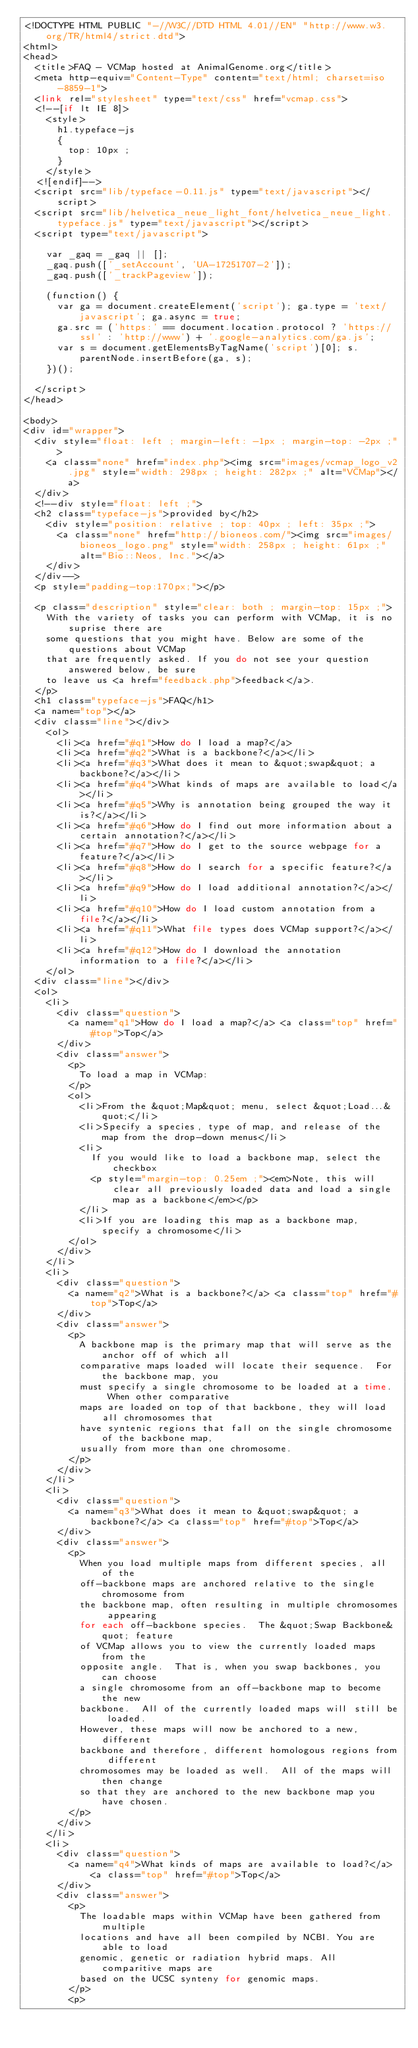<code> <loc_0><loc_0><loc_500><loc_500><_PHP_><!DOCTYPE HTML PUBLIC "-//W3C//DTD HTML 4.01//EN" "http://www.w3.org/TR/html4/strict.dtd">
<html>
<head>
  <title>FAQ - VCMap hosted at AnimalGenome.org</title>
  <meta http-equiv="Content-Type" content="text/html; charset=iso-8859-1">
  <link rel="stylesheet" type="text/css" href="vcmap.css">
  <!--[if lt IE 8]>
    <style>
      h1.typeface-js
      {
        top: 10px ;
      }
    </style>
  <![endif]-->
  <script src="lib/typeface-0.11.js" type="text/javascript"></script>
  <script src="lib/helvetica_neue_light_font/helvetica_neue_light.typeface.js" type="text/javascript"></script>
  <script type="text/javascript">

    var _gaq = _gaq || [];
    _gaq.push(['_setAccount', 'UA-17251707-2']);
    _gaq.push(['_trackPageview']);

    (function() {
      var ga = document.createElement('script'); ga.type = 'text/javascript'; ga.async = true;
      ga.src = ('https:' == document.location.protocol ? 'https://ssl' : 'http://www') + '.google-analytics.com/ga.js';
      var s = document.getElementsByTagName('script')[0]; s.parentNode.insertBefore(ga, s);
    })();

  </script>
</head>

<body>
<div id="wrapper">
  <div style="float: left ; margin-left: -1px ; margin-top: -2px ;">
    <a class="none" href="index.php"><img src="images/vcmap_logo_v2.jpg" style="width: 298px ; height: 282px ;" alt="VCMap"></a>
  </div>
  <!--div style="float: left ;">
  <h2 class="typeface-js">provided by</h2>
    <div style="position: relative ; top: 40px ; left: 35px ;">
      <a class="none" href="http://bioneos.com/"><img src="images/bioneos_logo.png" style="width: 258px ; height: 61px ;" alt="Bio::Neos, Inc."></a>
    </div>
  </div-->
  <p style="padding-top:170px;"></p>

  <p class="description" style="clear: both ; margin-top: 15px ;">
    With the variety of tasks you can perform with VCMap, it is no suprise there are
    some questions that you might have. Below are some of the questions about VCMap
    that are frequently asked. If you do not see your question answered below, be sure
    to leave us <a href="feedback.php">feedback</a>.
  </p>
  <h1 class="typeface-js">FAQ</h1>
  <a name="top"></a>
  <div class="line"></div>
    <ol>
      <li><a href="#q1">How do I load a map?</a>
      <li><a href="#q2">What is a backbone?</a></li>
      <li><a href="#q3">What does it mean to &quot;swap&quot; a backbone?</a></li>
      <li><a href="#q4">What kinds of maps are available to load</a></li>
      <li><a href="#q5">Why is annotation being grouped the way it is?</a></li>
      <li><a href="#q6">How do I find out more information about a certain annotation?</a></li>
      <li><a href="#q7">How do I get to the source webpage for a feature?</a></li>
      <li><a href="#q8">How do I search for a specific feature?</a></li>
      <li><a href="#q9">How do I load additional annotation?</a></li>
      <li><a href="#q10">How do I load custom annotation from a file?</a></li>
      <li><a href="#q11">What file types does VCMap support?</a></li>
      <li><a href="#q12">How do I download the annotation information to a file?</a></li>
    </ol>
  <div class="line"></div>
  <ol>
    <li>
      <div class="question">
        <a name="q1">How do I load a map?</a> <a class="top" href="#top">Top</a>
      </div>
      <div class="answer">
        <p>
          To load a map in VCMap:
        </p>
        <ol>
          <li>From the &quot;Map&quot; menu, select &quot;Load...&quot;</li>
          <li>Specify a species, type of map, and release of the map from the drop-down menus</li>
          <li>
            If you would like to load a backbone map, select the checkbox
            <p style="margin-top: 0.25em ;"><em>Note, this will clear all previously loaded data and load a single map as a backbone</em></p>
          </li>
          <li>If you are loading this map as a backbone map, specify a chromosome</li>
        </ol>
      </div>
    </li>
    <li>
      <div class="question">
        <a name="q2">What is a backbone?</a> <a class="top" href="#top">Top</a>
      </div>
      <div class="answer">
        <p>
          A backbone map is the primary map that will serve as the anchor off of which all
          comparative maps loaded will locate their sequence.  For the backbone map, you
          must specify a single chromosome to be loaded at a time.  When other comparative
          maps are loaded on top of that backbone, they will load all chromosomes that
          have syntenic regions that fall on the single chromosome of the backbone map,
          usually from more than one chromosome.
        </p>
      </div>
    </li>
    <li>
      <div class="question">
        <a name="q3">What does it mean to &quot;swap&quot; a backbone?</a> <a class="top" href="#top">Top</a>
      </div>
      <div class="answer">
        <p>
          When you load multiple maps from different species, all of the
          off-backbone maps are anchored relative to the single chromosome from
          the backbone map, often resulting in multiple chromosomes appearing
          for each off-backbone species.  The &quot;Swap Backbone&quot; feature
          of VCMap allows you to view the currently loaded maps from the
          opposite angle.  That is, when you swap backbones, you can choose
          a single chromosome from an off-backbone map to become the new
          backbone.  All of the currently loaded maps will still be loaded.
          However, these maps will now be anchored to a new, different 
          backbone and therefore, different homologous regions from different
          chromosomes may be loaded as well.  All of the maps will then change
          so that they are anchored to the new backbone map you have chosen.
        </p>
      </div>
    </li>
    <li>
      <div class="question">
        <a name="q4">What kinds of maps are available to load?</a> <a class="top" href="#top">Top</a>
      </div>
      <div class="answer">
        <p>
          The loadable maps within VCMap have been gathered from multiple
          locations and have all been compiled by NCBI. You are able to load
          genomic, genetic or radiation hybrid maps. All comparitive maps are
          based on the UCSC synteny for genomic maps.
        </p>
        <p></code> 